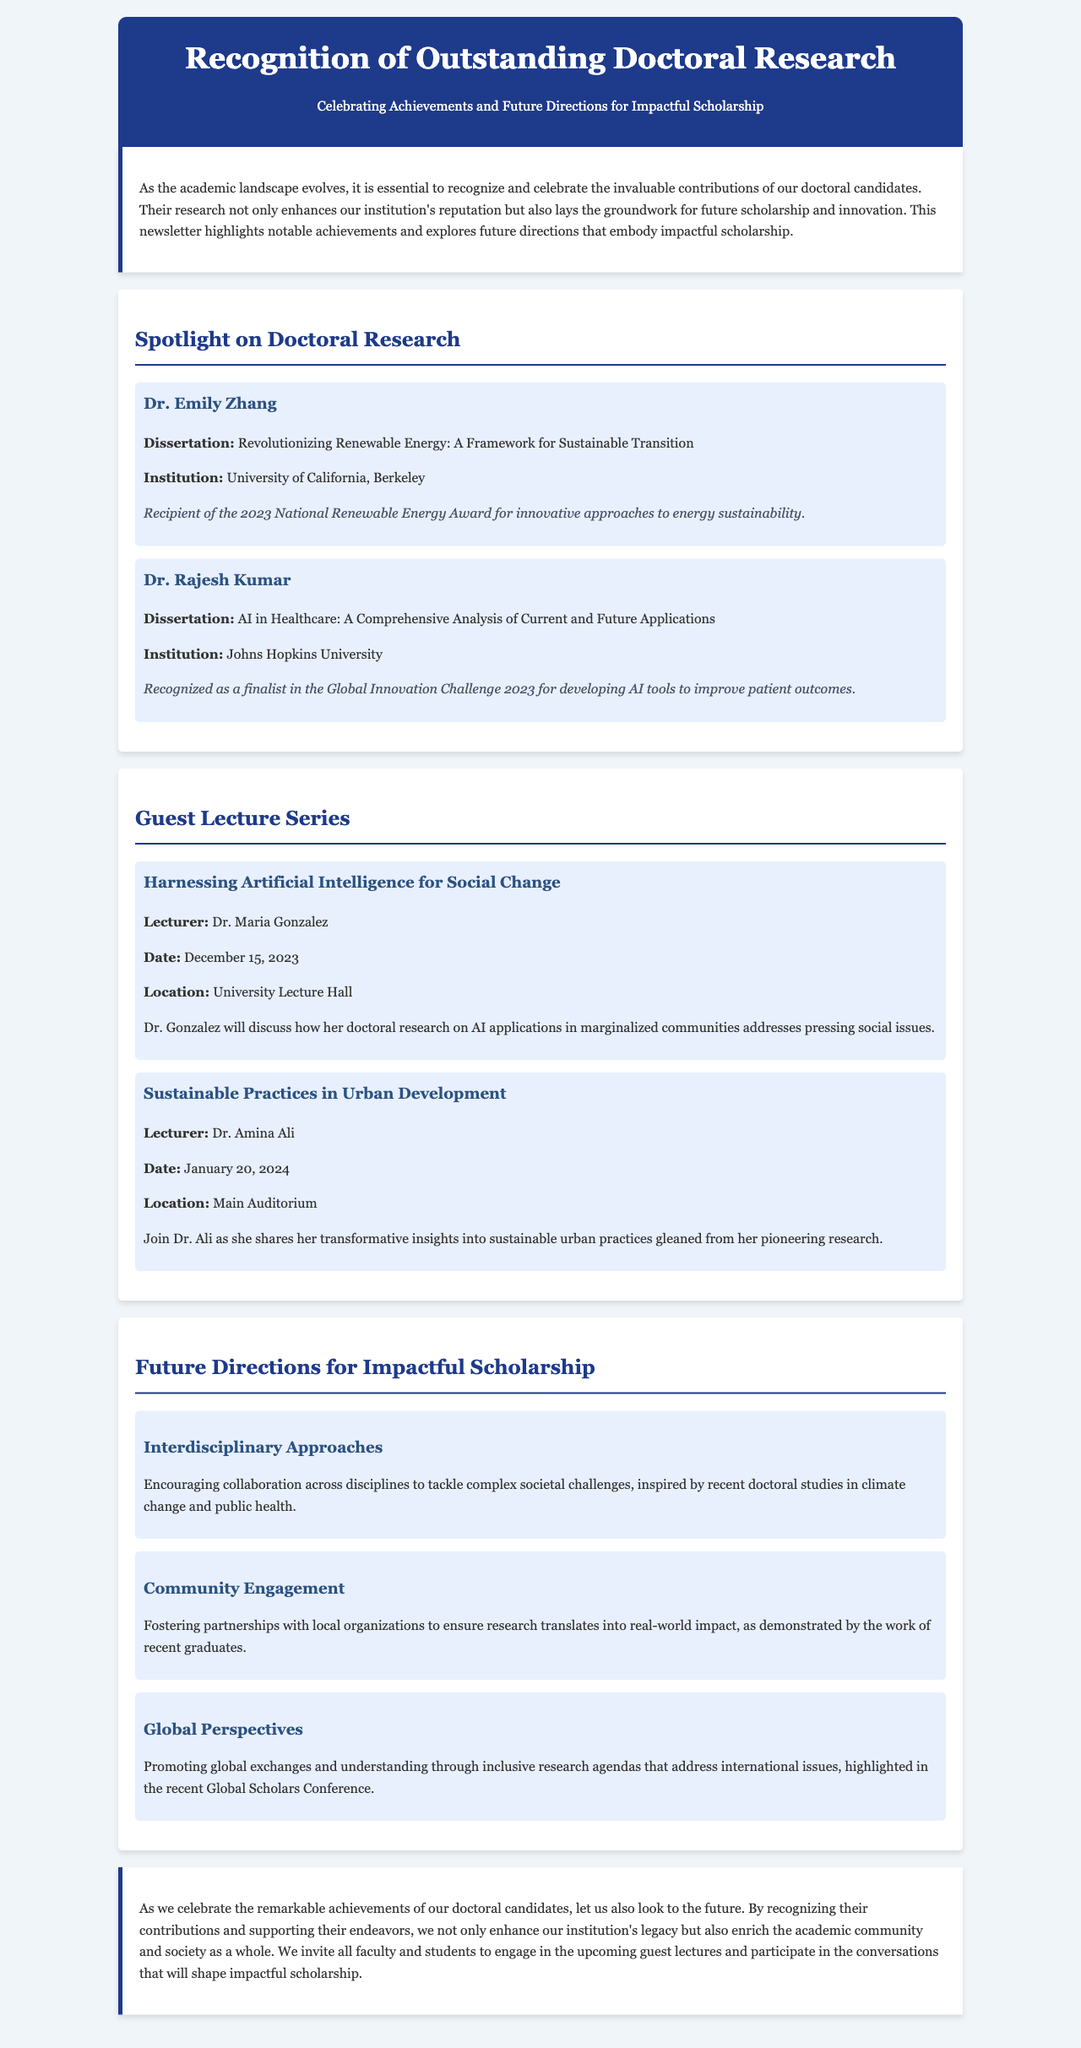What is the title of Dr. Emily Zhang's dissertation? The title can be found in the spotlight section under her name, which is "Revolutionizing Renewable Energy: A Framework for Sustainable Transition."
Answer: Revolutionizing Renewable Energy: A Framework for Sustainable Transition What award did Dr. Rajesh Kumar receive? The document mentions that Dr. Rajesh Kumar was recognized as a finalist in a specific competition, the Global Innovation Challenge 2023.
Answer: Global Innovation Challenge 2023 What date is Dr. Maria Gonzalez's lecture scheduled for? The date for Dr. Maria Gonzalez's lecture can be found in the guest lecture section, listed under her name.
Answer: December 15, 2023 What future direction emphasizes partnerships with local organizations? The future direction focusing on partnerships is specified in the text discussing "Community Engagement."
Answer: Community Engagement Who is scheduled to speak about sustainable practices in urban development? The lecturer for this topic is identified in the guest lecture section as Dr. Amina Ali.
Answer: Dr. Amina Ali What is the main theme of the newsletter? The main theme is outlined in the introduction where it states the purpose of recognizing doctoral candidates' contributions to scholarship.
Answer: Celebrating Achievements and Future Directions for Impactful Scholarship Which university is Dr. Emily Zhang affiliated with? The document includes Dr. Emily Zhang's institutional affiliation, which is noted in her spotlight section.
Answer: University of California, Berkeley What color is used for the header background? The header background color is described in the style section of the document.
Answer: #1e3a8a 